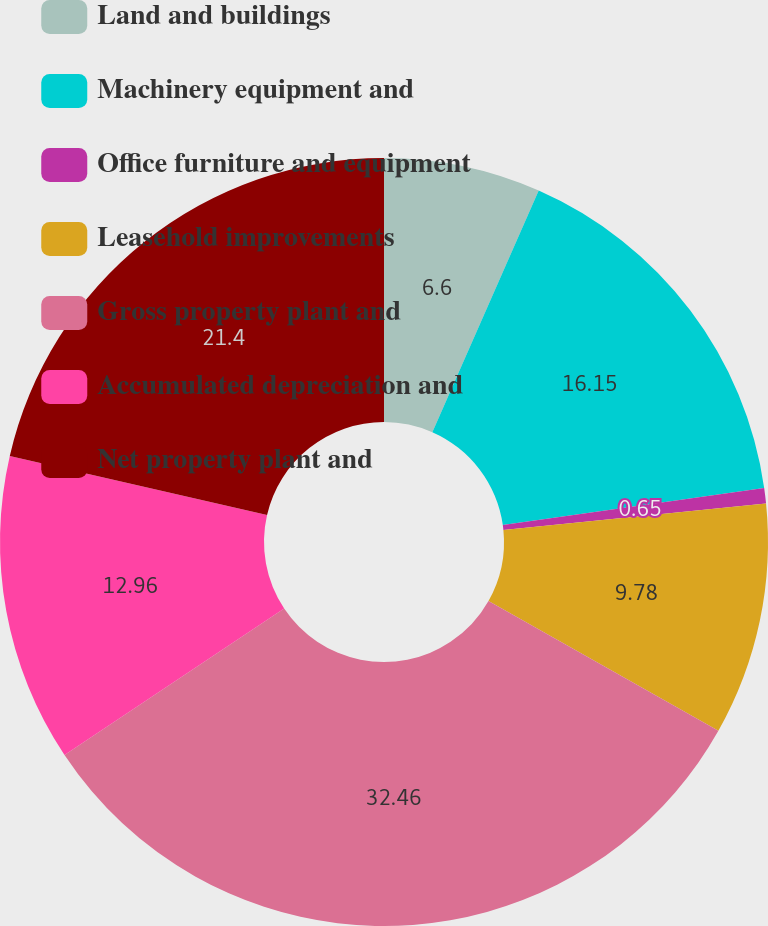Convert chart. <chart><loc_0><loc_0><loc_500><loc_500><pie_chart><fcel>Land and buildings<fcel>Machinery equipment and<fcel>Office furniture and equipment<fcel>Leasehold improvements<fcel>Gross property plant and<fcel>Accumulated depreciation and<fcel>Net property plant and<nl><fcel>6.6%<fcel>16.15%<fcel>0.65%<fcel>9.78%<fcel>32.46%<fcel>12.96%<fcel>21.4%<nl></chart> 